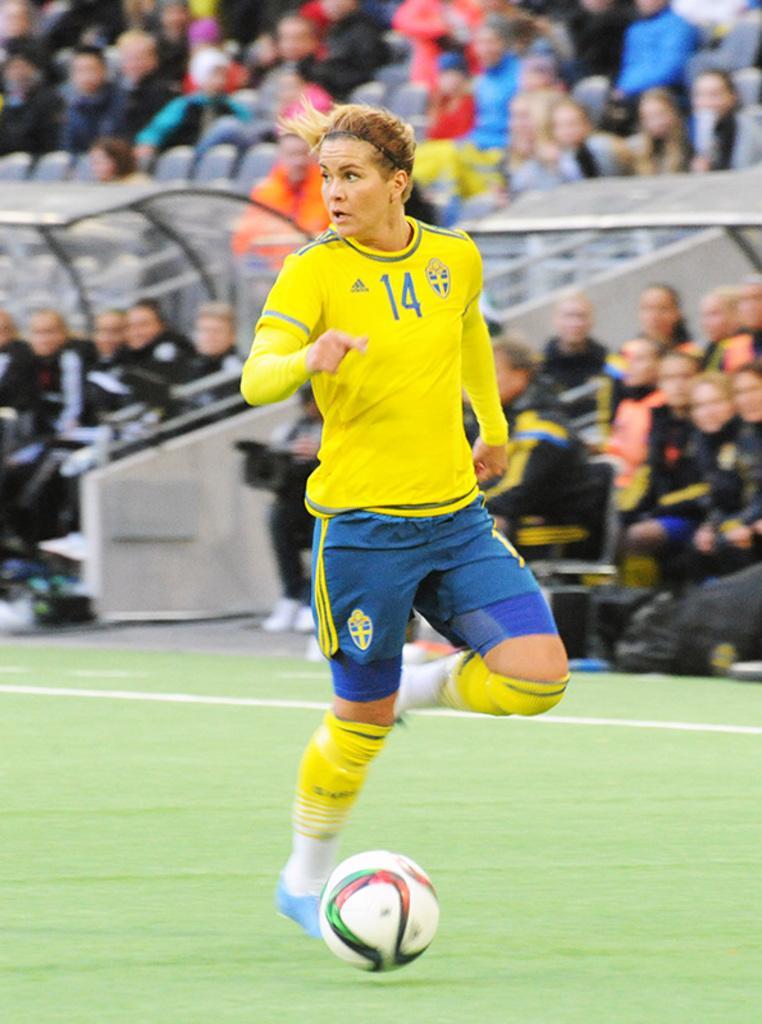In one or two sentences, can you explain what this image depicts? In this image we can see a woman running on the ground, and here is the ball, and at back a group of people are sitting. 